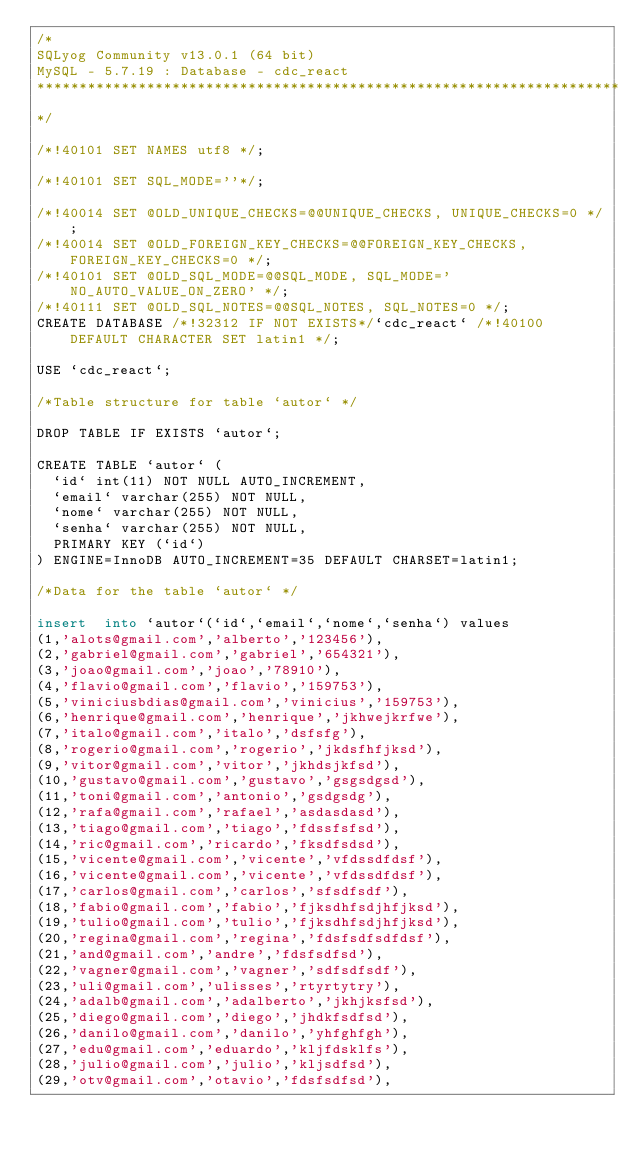<code> <loc_0><loc_0><loc_500><loc_500><_SQL_>/*
SQLyog Community v13.0.1 (64 bit)
MySQL - 5.7.19 : Database - cdc_react
*********************************************************************
*/

/*!40101 SET NAMES utf8 */;

/*!40101 SET SQL_MODE=''*/;

/*!40014 SET @OLD_UNIQUE_CHECKS=@@UNIQUE_CHECKS, UNIQUE_CHECKS=0 */;
/*!40014 SET @OLD_FOREIGN_KEY_CHECKS=@@FOREIGN_KEY_CHECKS, FOREIGN_KEY_CHECKS=0 */;
/*!40101 SET @OLD_SQL_MODE=@@SQL_MODE, SQL_MODE='NO_AUTO_VALUE_ON_ZERO' */;
/*!40111 SET @OLD_SQL_NOTES=@@SQL_NOTES, SQL_NOTES=0 */;
CREATE DATABASE /*!32312 IF NOT EXISTS*/`cdc_react` /*!40100 DEFAULT CHARACTER SET latin1 */;

USE `cdc_react`;

/*Table structure for table `autor` */

DROP TABLE IF EXISTS `autor`;

CREATE TABLE `autor` (
  `id` int(11) NOT NULL AUTO_INCREMENT,
  `email` varchar(255) NOT NULL,
  `nome` varchar(255) NOT NULL,
  `senha` varchar(255) NOT NULL,
  PRIMARY KEY (`id`)
) ENGINE=InnoDB AUTO_INCREMENT=35 DEFAULT CHARSET=latin1;

/*Data for the table `autor` */

insert  into `autor`(`id`,`email`,`nome`,`senha`) values 
(1,'alots@gmail.com','alberto','123456'),
(2,'gabriel@gmail.com','gabriel','654321'),
(3,'joao@gmail.com','joao','78910'),
(4,'flavio@gmail.com','flavio','159753'),
(5,'viniciusbdias@gmail.com','vinicius','159753'),
(6,'henrique@gmail.com','henrique','jkhwejkrfwe'),
(7,'italo@gmail.com','italo','dsfsfg'),
(8,'rogerio@gmail.com','rogerio','jkdsfhfjksd'),
(9,'vitor@gmail.com','vitor','jkhdsjkfsd'),
(10,'gustavo@gmail.com','gustavo','gsgsdgsd'),
(11,'toni@gmail.com','antonio','gsdgsdg'),
(12,'rafa@gmail.com','rafael','asdasdasd'),
(13,'tiago@gmail.com','tiago','fdssfsfsd'),
(14,'ric@gmail.com','ricardo','fksdfsdsd'),
(15,'vicente@gmail.com','vicente','vfdssdfdsf'),
(16,'vicente@gmail.com','vicente','vfdssdfdsf'),
(17,'carlos@gmail.com','carlos','sfsdfsdf'),
(18,'fabio@gmail.com','fabio','fjksdhfsdjhfjksd'),
(19,'tulio@gmail.com','tulio','fjksdhfsdjhfjksd'),
(20,'regina@gmail.com','regina','fdsfsdfsdfdsf'),
(21,'and@gmail.com','andre','fdsfsdfsd'),
(22,'vagner@gmail.com','vagner','sdfsdfsdf'),
(23,'uli@gmail.com','ulisses','rtyrtytry'),
(24,'adalb@gmail.com','adalberto','jkhjksfsd'),
(25,'diego@gmail.com','diego','jhdkfsdfsd'),
(26,'danilo@gmail.com','danilo','yhfghfgh'),
(27,'edu@gmail.com','eduardo','kljfdsklfs'),
(28,'julio@gmail.com','julio','kljsdfsd'),
(29,'otv@gmail.com','otavio','fdsfsdfsd'),</code> 